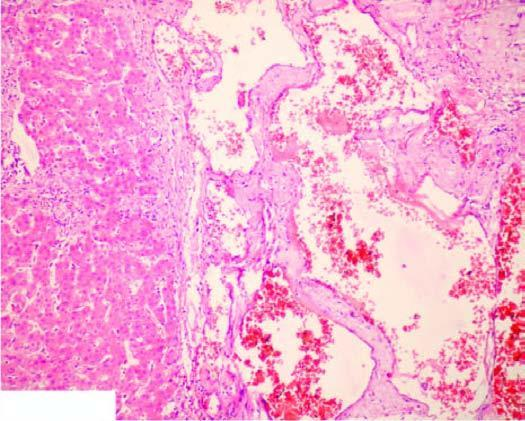re orifices of some of the branches coming out of the wall large, dilated, many containing blood, and are lined by flattened endothelial cells?
Answer the question using a single word or phrase. No 